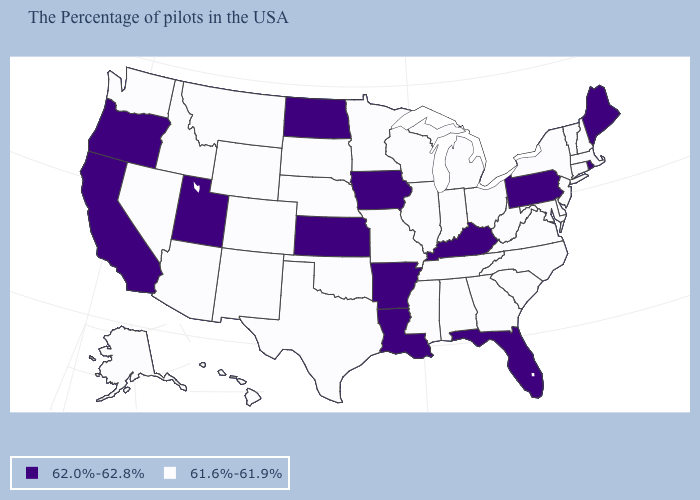Does Colorado have a lower value than Louisiana?
Concise answer only. Yes. Does the first symbol in the legend represent the smallest category?
Answer briefly. No. What is the value of North Carolina?
Be succinct. 61.6%-61.9%. What is the value of Maine?
Answer briefly. 62.0%-62.8%. What is the lowest value in the MidWest?
Keep it brief. 61.6%-61.9%. What is the highest value in states that border Massachusetts?
Answer briefly. 62.0%-62.8%. Name the states that have a value in the range 62.0%-62.8%?
Be succinct. Maine, Rhode Island, Pennsylvania, Florida, Kentucky, Louisiana, Arkansas, Iowa, Kansas, North Dakota, Utah, California, Oregon. What is the value of Oklahoma?
Answer briefly. 61.6%-61.9%. Does Oregon have the highest value in the West?
Concise answer only. Yes. Name the states that have a value in the range 61.6%-61.9%?
Concise answer only. Massachusetts, New Hampshire, Vermont, Connecticut, New York, New Jersey, Delaware, Maryland, Virginia, North Carolina, South Carolina, West Virginia, Ohio, Georgia, Michigan, Indiana, Alabama, Tennessee, Wisconsin, Illinois, Mississippi, Missouri, Minnesota, Nebraska, Oklahoma, Texas, South Dakota, Wyoming, Colorado, New Mexico, Montana, Arizona, Idaho, Nevada, Washington, Alaska, Hawaii. Does Pennsylvania have the same value as North Carolina?
Give a very brief answer. No. Name the states that have a value in the range 61.6%-61.9%?
Be succinct. Massachusetts, New Hampshire, Vermont, Connecticut, New York, New Jersey, Delaware, Maryland, Virginia, North Carolina, South Carolina, West Virginia, Ohio, Georgia, Michigan, Indiana, Alabama, Tennessee, Wisconsin, Illinois, Mississippi, Missouri, Minnesota, Nebraska, Oklahoma, Texas, South Dakota, Wyoming, Colorado, New Mexico, Montana, Arizona, Idaho, Nevada, Washington, Alaska, Hawaii. Among the states that border Utah , which have the highest value?
Give a very brief answer. Wyoming, Colorado, New Mexico, Arizona, Idaho, Nevada. Name the states that have a value in the range 61.6%-61.9%?
Be succinct. Massachusetts, New Hampshire, Vermont, Connecticut, New York, New Jersey, Delaware, Maryland, Virginia, North Carolina, South Carolina, West Virginia, Ohio, Georgia, Michigan, Indiana, Alabama, Tennessee, Wisconsin, Illinois, Mississippi, Missouri, Minnesota, Nebraska, Oklahoma, Texas, South Dakota, Wyoming, Colorado, New Mexico, Montana, Arizona, Idaho, Nevada, Washington, Alaska, Hawaii. What is the highest value in the West ?
Keep it brief. 62.0%-62.8%. 